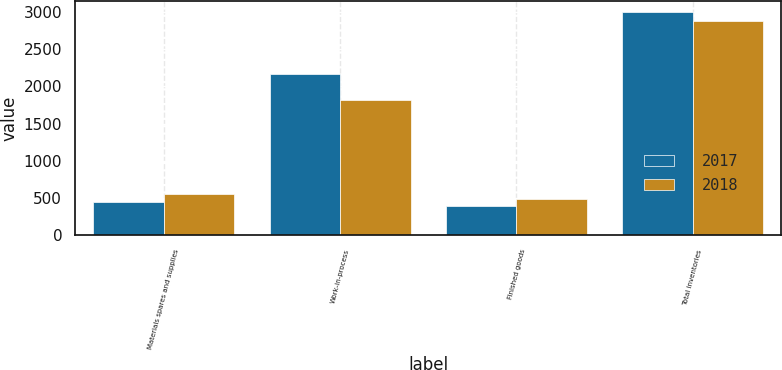Convert chart to OTSL. <chart><loc_0><loc_0><loc_500><loc_500><stacked_bar_chart><ecel><fcel>Materials spares and supplies<fcel>Work-in-process<fcel>Finished goods<fcel>Total inventories<nl><fcel>2017<fcel>446<fcel>2161<fcel>390<fcel>2997<nl><fcel>2018<fcel>563<fcel>1823<fcel>492<fcel>2878<nl></chart> 